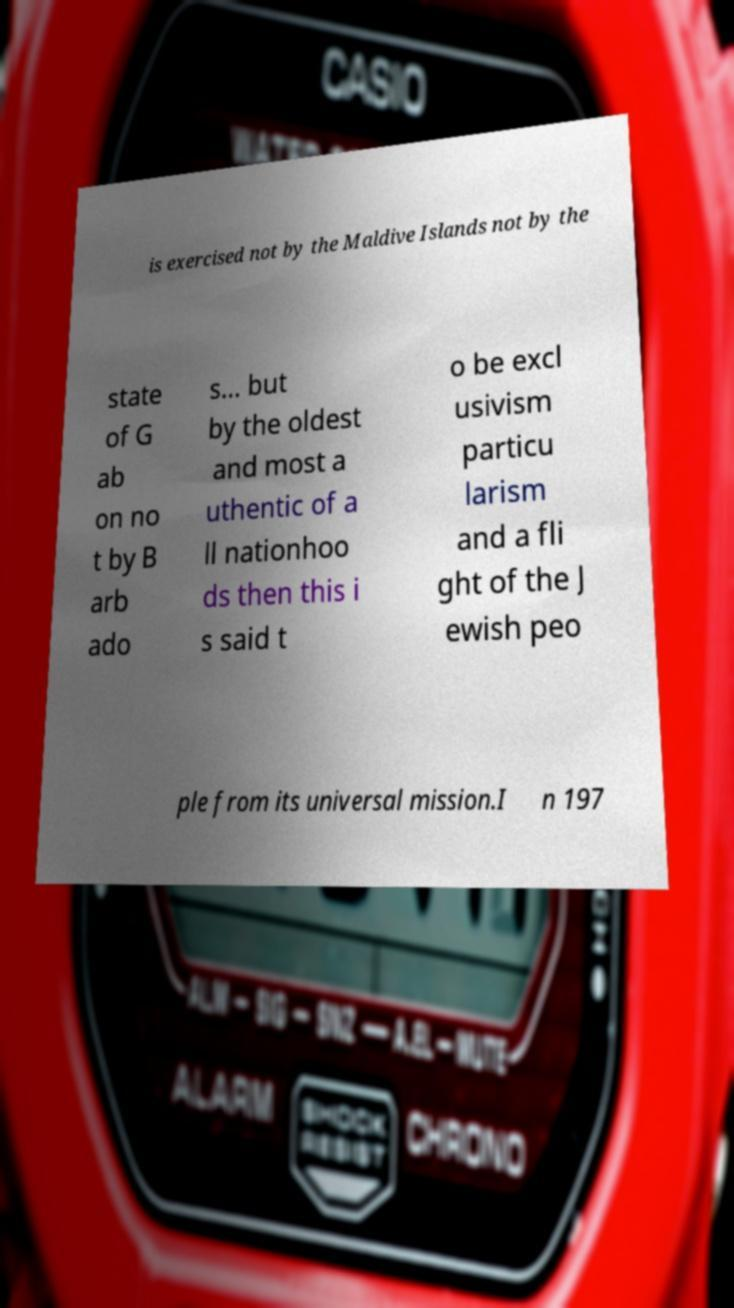Can you accurately transcribe the text from the provided image for me? is exercised not by the Maldive Islands not by the state of G ab on no t by B arb ado s… but by the oldest and most a uthentic of a ll nationhoo ds then this i s said t o be excl usivism particu larism and a fli ght of the J ewish peo ple from its universal mission.I n 197 